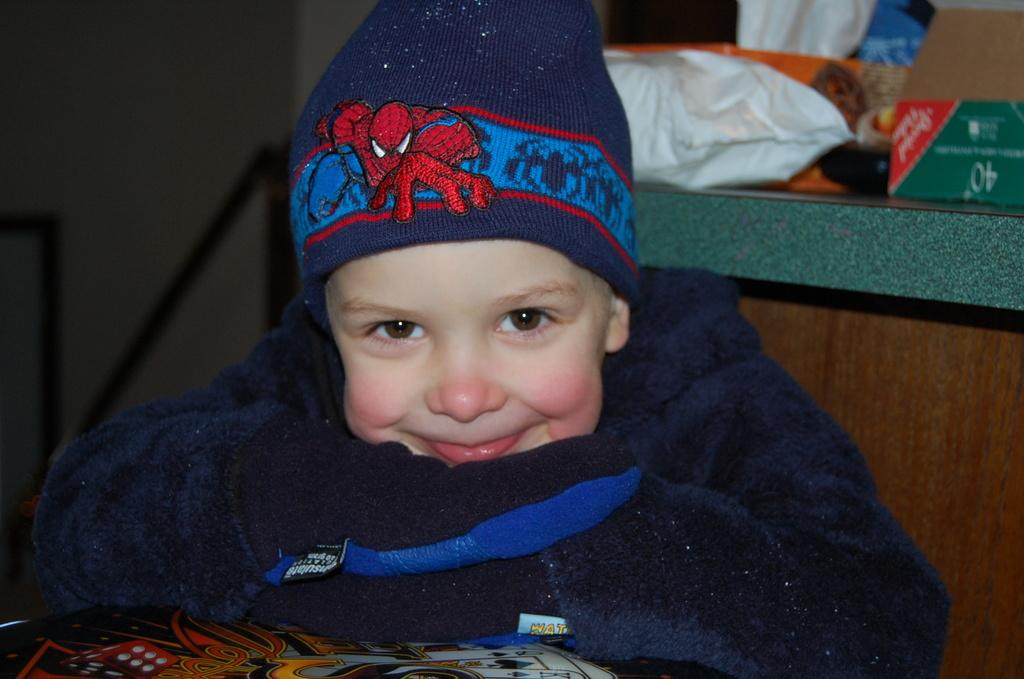What is the main subject of the image? The main subject of the image is a kid. What is the kid doing in the image? The kid is smiling in the image. What can be seen in the foreground of the image? There is a board in the image. What is visible in the background of the image? There is a box, objects on a platform, and a wall in the background of the image. What type of pocket can be seen on the kid's clothing in the image? There is no pocket visible on the kid's clothing in the image. Where is the playground located in the image? There is no playground present in the image. 